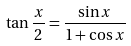Convert formula to latex. <formula><loc_0><loc_0><loc_500><loc_500>\tan \frac { x } { 2 } = \frac { \sin x } { 1 + \cos x }</formula> 